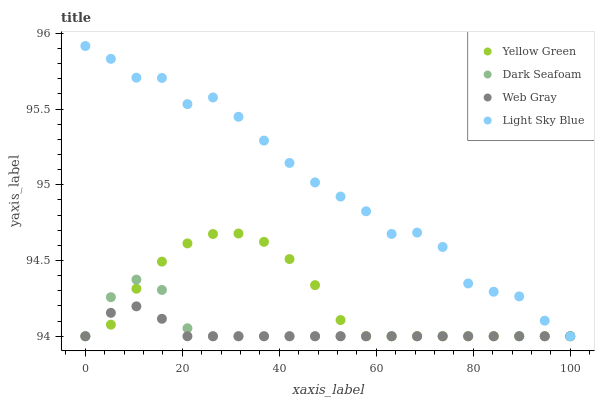Does Web Gray have the minimum area under the curve?
Answer yes or no. Yes. Does Light Sky Blue have the maximum area under the curve?
Answer yes or no. Yes. Does Yellow Green have the minimum area under the curve?
Answer yes or no. No. Does Yellow Green have the maximum area under the curve?
Answer yes or no. No. Is Web Gray the smoothest?
Answer yes or no. Yes. Is Light Sky Blue the roughest?
Answer yes or no. Yes. Is Yellow Green the smoothest?
Answer yes or no. No. Is Yellow Green the roughest?
Answer yes or no. No. Does Dark Seafoam have the lowest value?
Answer yes or no. Yes. Does Light Sky Blue have the highest value?
Answer yes or no. Yes. Does Yellow Green have the highest value?
Answer yes or no. No. Does Web Gray intersect Light Sky Blue?
Answer yes or no. Yes. Is Web Gray less than Light Sky Blue?
Answer yes or no. No. Is Web Gray greater than Light Sky Blue?
Answer yes or no. No. 